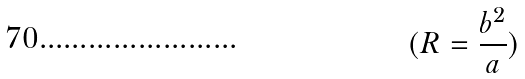Convert formula to latex. <formula><loc_0><loc_0><loc_500><loc_500>( R = \frac { b ^ { 2 } } { a } )</formula> 